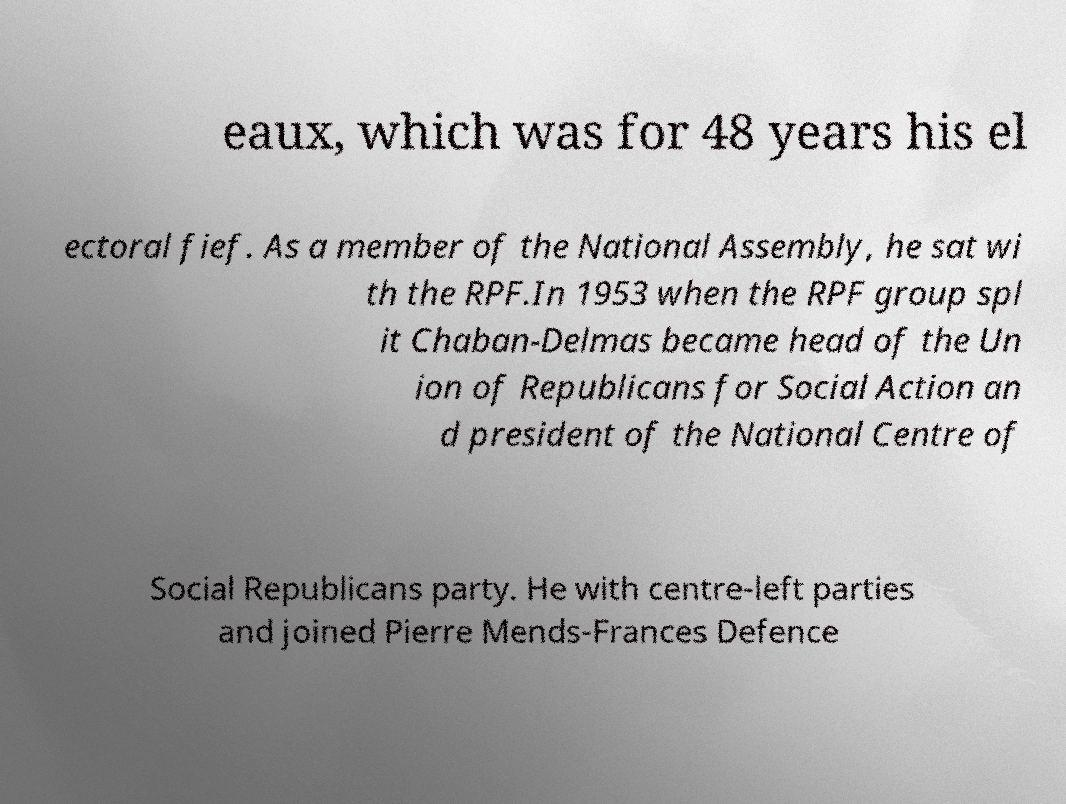Could you assist in decoding the text presented in this image and type it out clearly? eaux, which was for 48 years his el ectoral fief. As a member of the National Assembly, he sat wi th the RPF.In 1953 when the RPF group spl it Chaban-Delmas became head of the Un ion of Republicans for Social Action an d president of the National Centre of Social Republicans party. He with centre-left parties and joined Pierre Mends-Frances Defence 